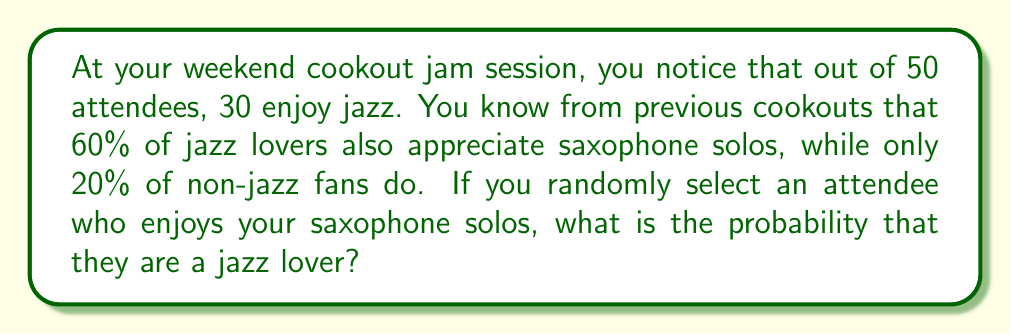Help me with this question. Let's approach this using Bayesian inference:

1) Define our events:
   J: The person is a jazz lover
   S: The person enjoys saxophone solos

2) Given information:
   P(J) = 30/50 = 0.6 (prior probability of being a jazz lover)
   P(S|J) = 0.6 (probability of enjoying saxophone solos given they're a jazz lover)
   P(S|not J) = 0.2 (probability of enjoying saxophone solos given they're not a jazz lover)

3) We need to find P(J|S) using Bayes' theorem:

   $$P(J|S) = \frac{P(S|J) \cdot P(J)}{P(S)}$$

4) Calculate P(S) using the law of total probability:
   
   $$P(S) = P(S|J) \cdot P(J) + P(S|not J) \cdot P(not J)$$
   $$P(S) = 0.6 \cdot 0.6 + 0.2 \cdot 0.4 = 0.36 + 0.08 = 0.44$$

5) Now we can apply Bayes' theorem:

   $$P(J|S) = \frac{0.6 \cdot 0.6}{0.44} = \frac{0.36}{0.44} = \frac{9}{11} \approx 0.8182$$

Thus, the probability that a randomly selected attendee who enjoys your saxophone solos is a jazz lover is approximately 0.8182 or about 81.82%.
Answer: $\frac{9}{11}$ or approximately 0.8182 